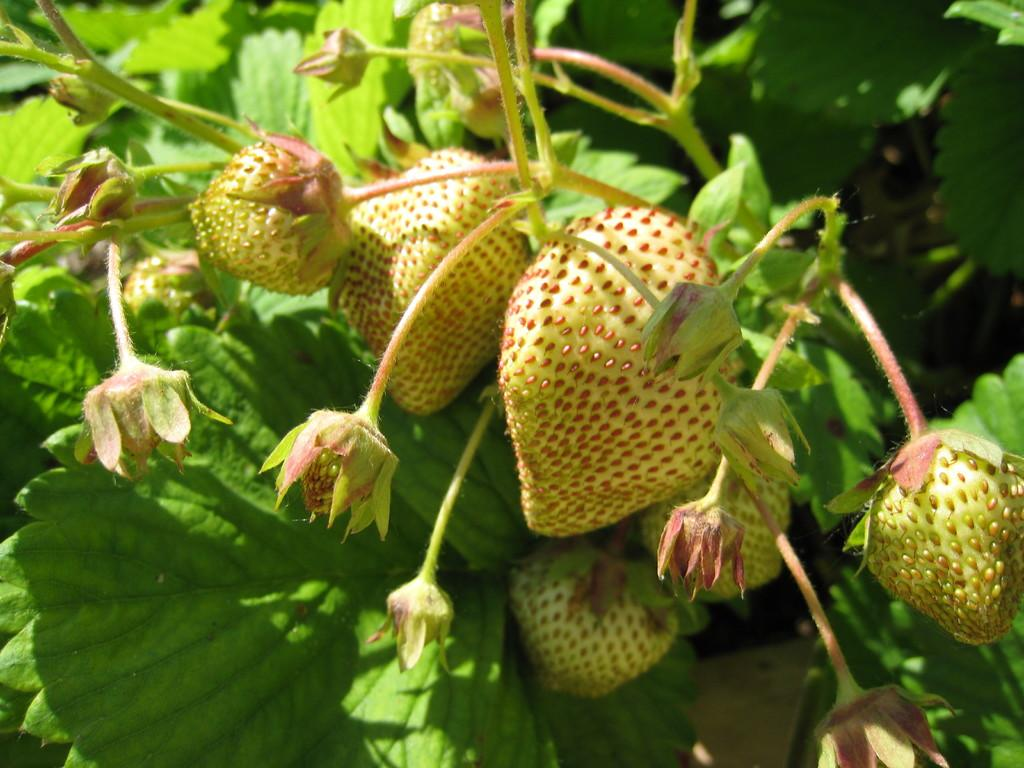What type of fruit is present in the image? There are strawberries in the image. Where are the strawberries located? The strawberries are on a plant. What is the name of the person who is whistling in the image? There is no person whistling in the image; it only features strawberries on a plant. 